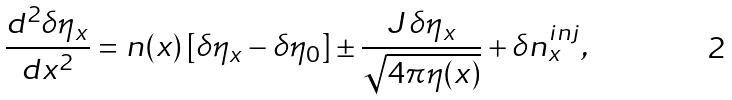<formula> <loc_0><loc_0><loc_500><loc_500>\frac { d ^ { 2 } \delta \eta _ { x } } { d x ^ { 2 } } = n ( x ) \, [ \delta \eta _ { x } - \delta \eta _ { 0 } ] \pm \frac { J \, \delta \eta _ { x } } { \sqrt { 4 \pi \eta ( x ) } } + \delta n _ { x } ^ { i n j } ,</formula> 